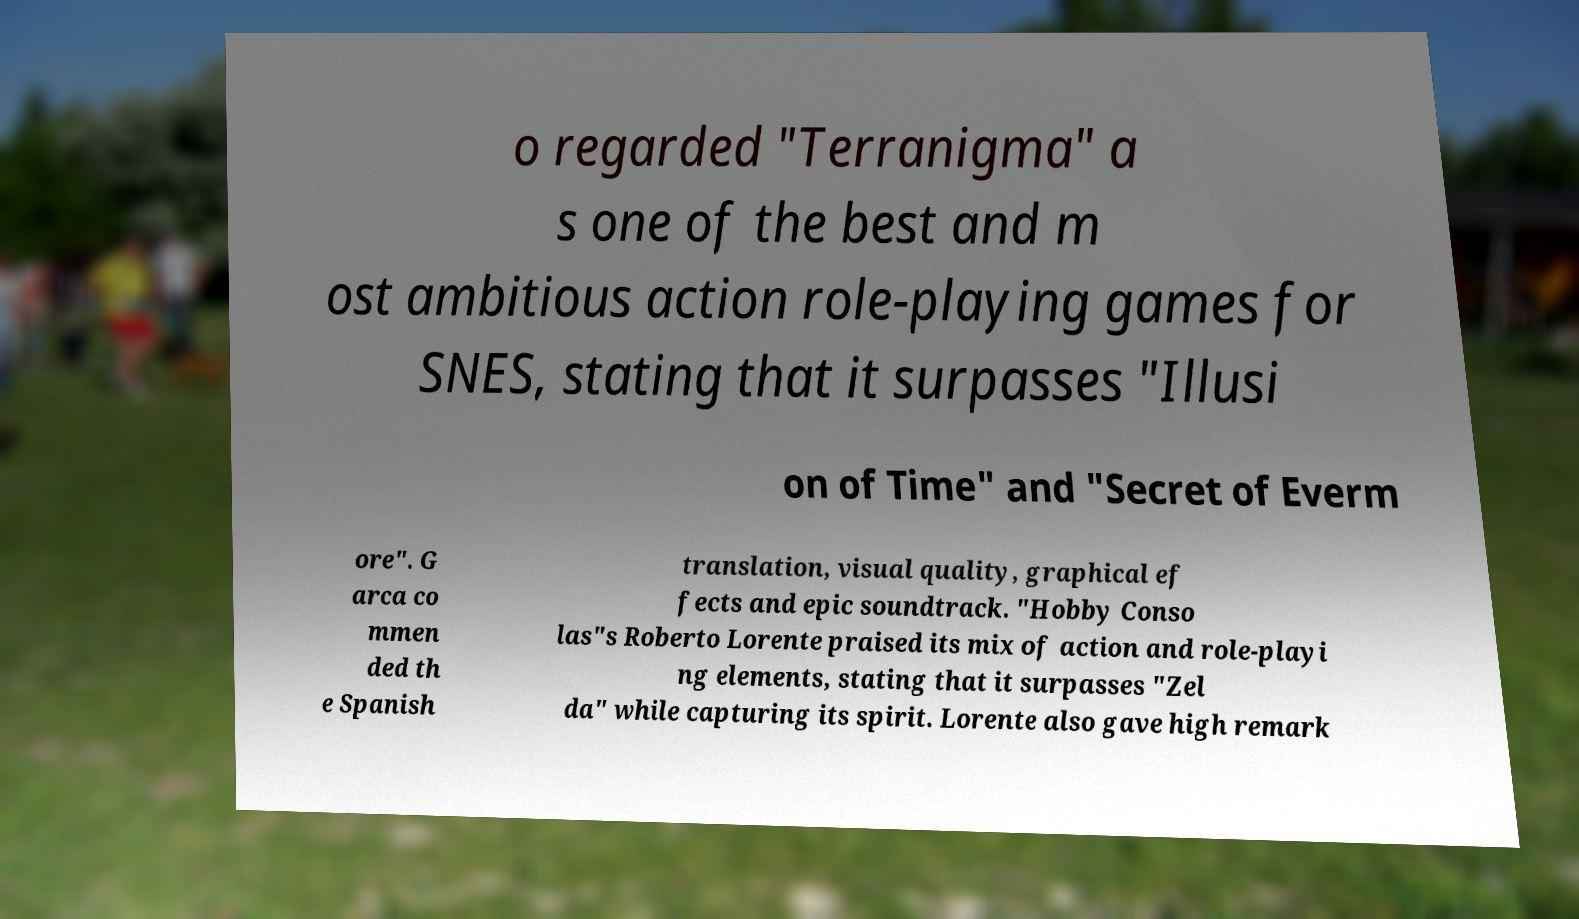Can you accurately transcribe the text from the provided image for me? o regarded "Terranigma" a s one of the best and m ost ambitious action role-playing games for SNES, stating that it surpasses "Illusi on of Time" and "Secret of Everm ore". G arca co mmen ded th e Spanish translation, visual quality, graphical ef fects and epic soundtrack. "Hobby Conso las"s Roberto Lorente praised its mix of action and role-playi ng elements, stating that it surpasses "Zel da" while capturing its spirit. Lorente also gave high remark 